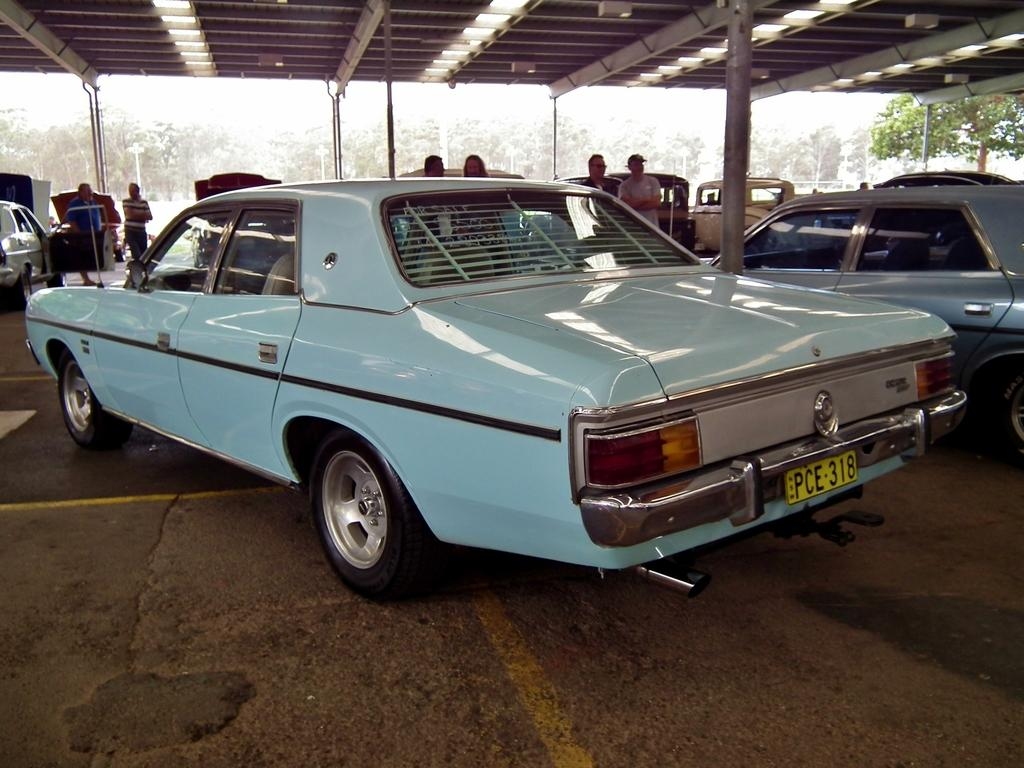What type of structure is present in the image? There is a shed in the image. What can be found inside the shed? There are vehicles inside the shed. Are there any people present in the image? Yes, there are people inside the shed. What can be seen in the background behind the people? There are trees visible behind the people. What is the position of the person's knee in the image? There is no specific knee position mentioned or visible in the image. 